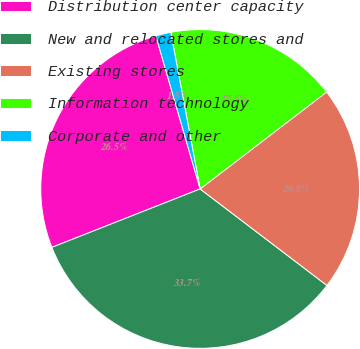Convert chart. <chart><loc_0><loc_0><loc_500><loc_500><pie_chart><fcel>Distribution center capacity<fcel>New and relocated stores and<fcel>Existing stores<fcel>Information technology<fcel>Corporate and other<nl><fcel>26.49%<fcel>33.67%<fcel>20.76%<fcel>17.54%<fcel>1.53%<nl></chart> 